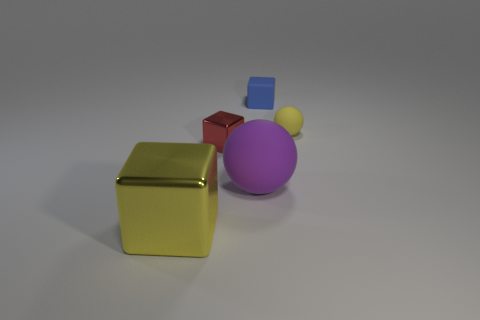Is the purple rubber thing the same shape as the tiny yellow object?
Your answer should be compact. Yes. Are there any other things that have the same color as the large rubber sphere?
Your answer should be compact. No. There is a yellow object behind the small metal cube; is it the same shape as the red thing?
Give a very brief answer. No. What is the material of the big cube?
Provide a succinct answer. Metal. What shape is the yellow object right of the rubber thing that is in front of the rubber ball right of the blue object?
Your answer should be very brief. Sphere. What number of other things are the same shape as the red thing?
Your answer should be compact. 2. Is the color of the tiny matte ball the same as the shiny cube that is behind the purple object?
Keep it short and to the point. No. How many gray blocks are there?
Offer a terse response. 0. How many things are small red objects or red balls?
Offer a very short reply. 1. There is a block that is the same color as the small ball; what size is it?
Provide a short and direct response. Large. 